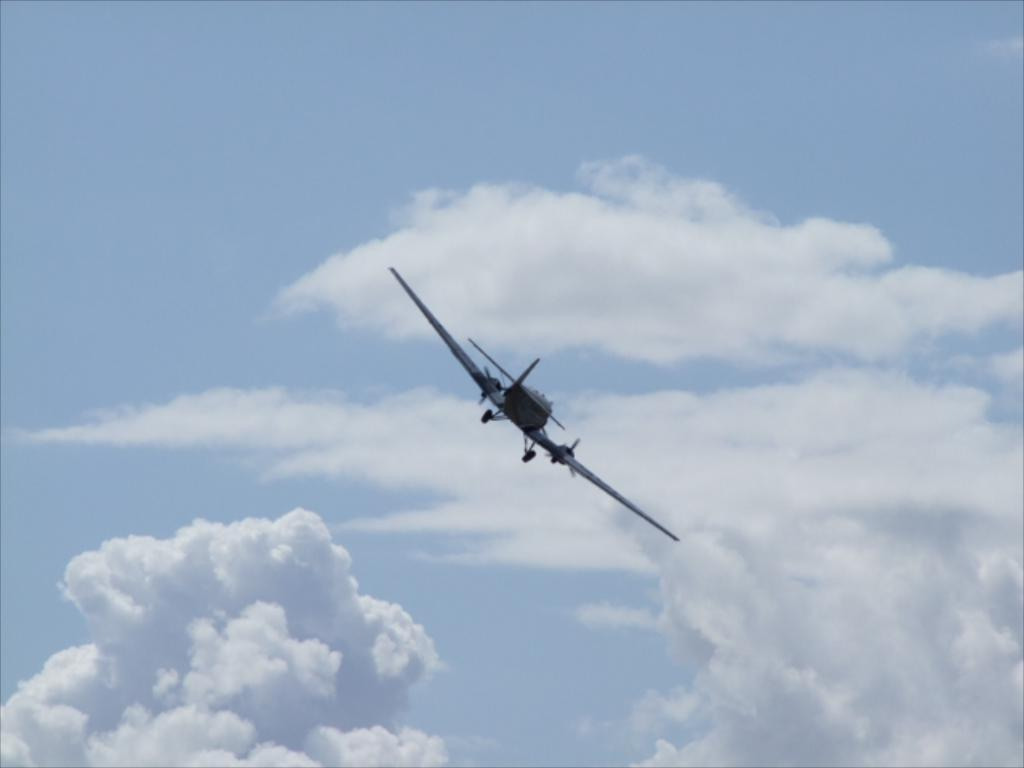What is the main subject of the image? The main subject of the image is a flying jet. Where is the jet located in the image? The jet is in the air. What can be seen in the background of the image? The sky is visible in the image. What is the weather like in the image? The sky is cloudy in the image. Can you see a worm resting on the gold surface in the image? There is no worm or gold surface present in the image. 